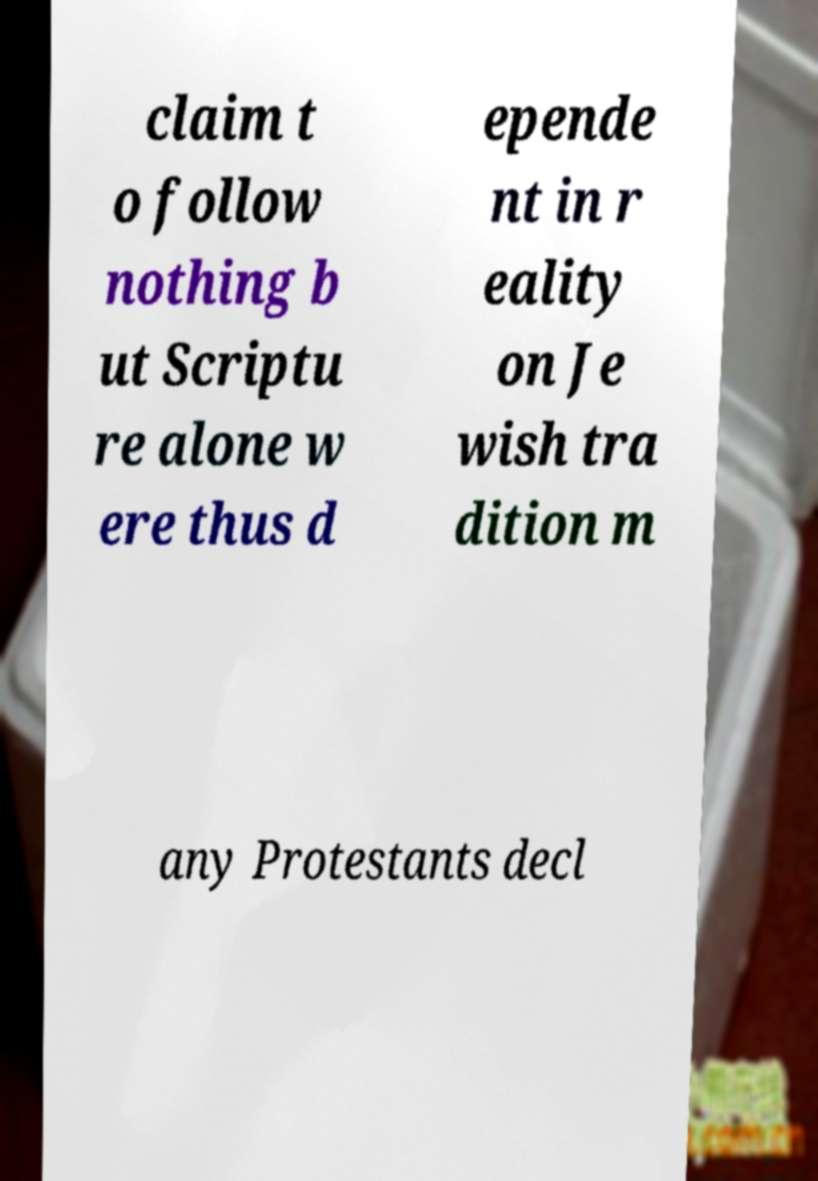Please read and relay the text visible in this image. What does it say? claim t o follow nothing b ut Scriptu re alone w ere thus d epende nt in r eality on Je wish tra dition m any Protestants decl 